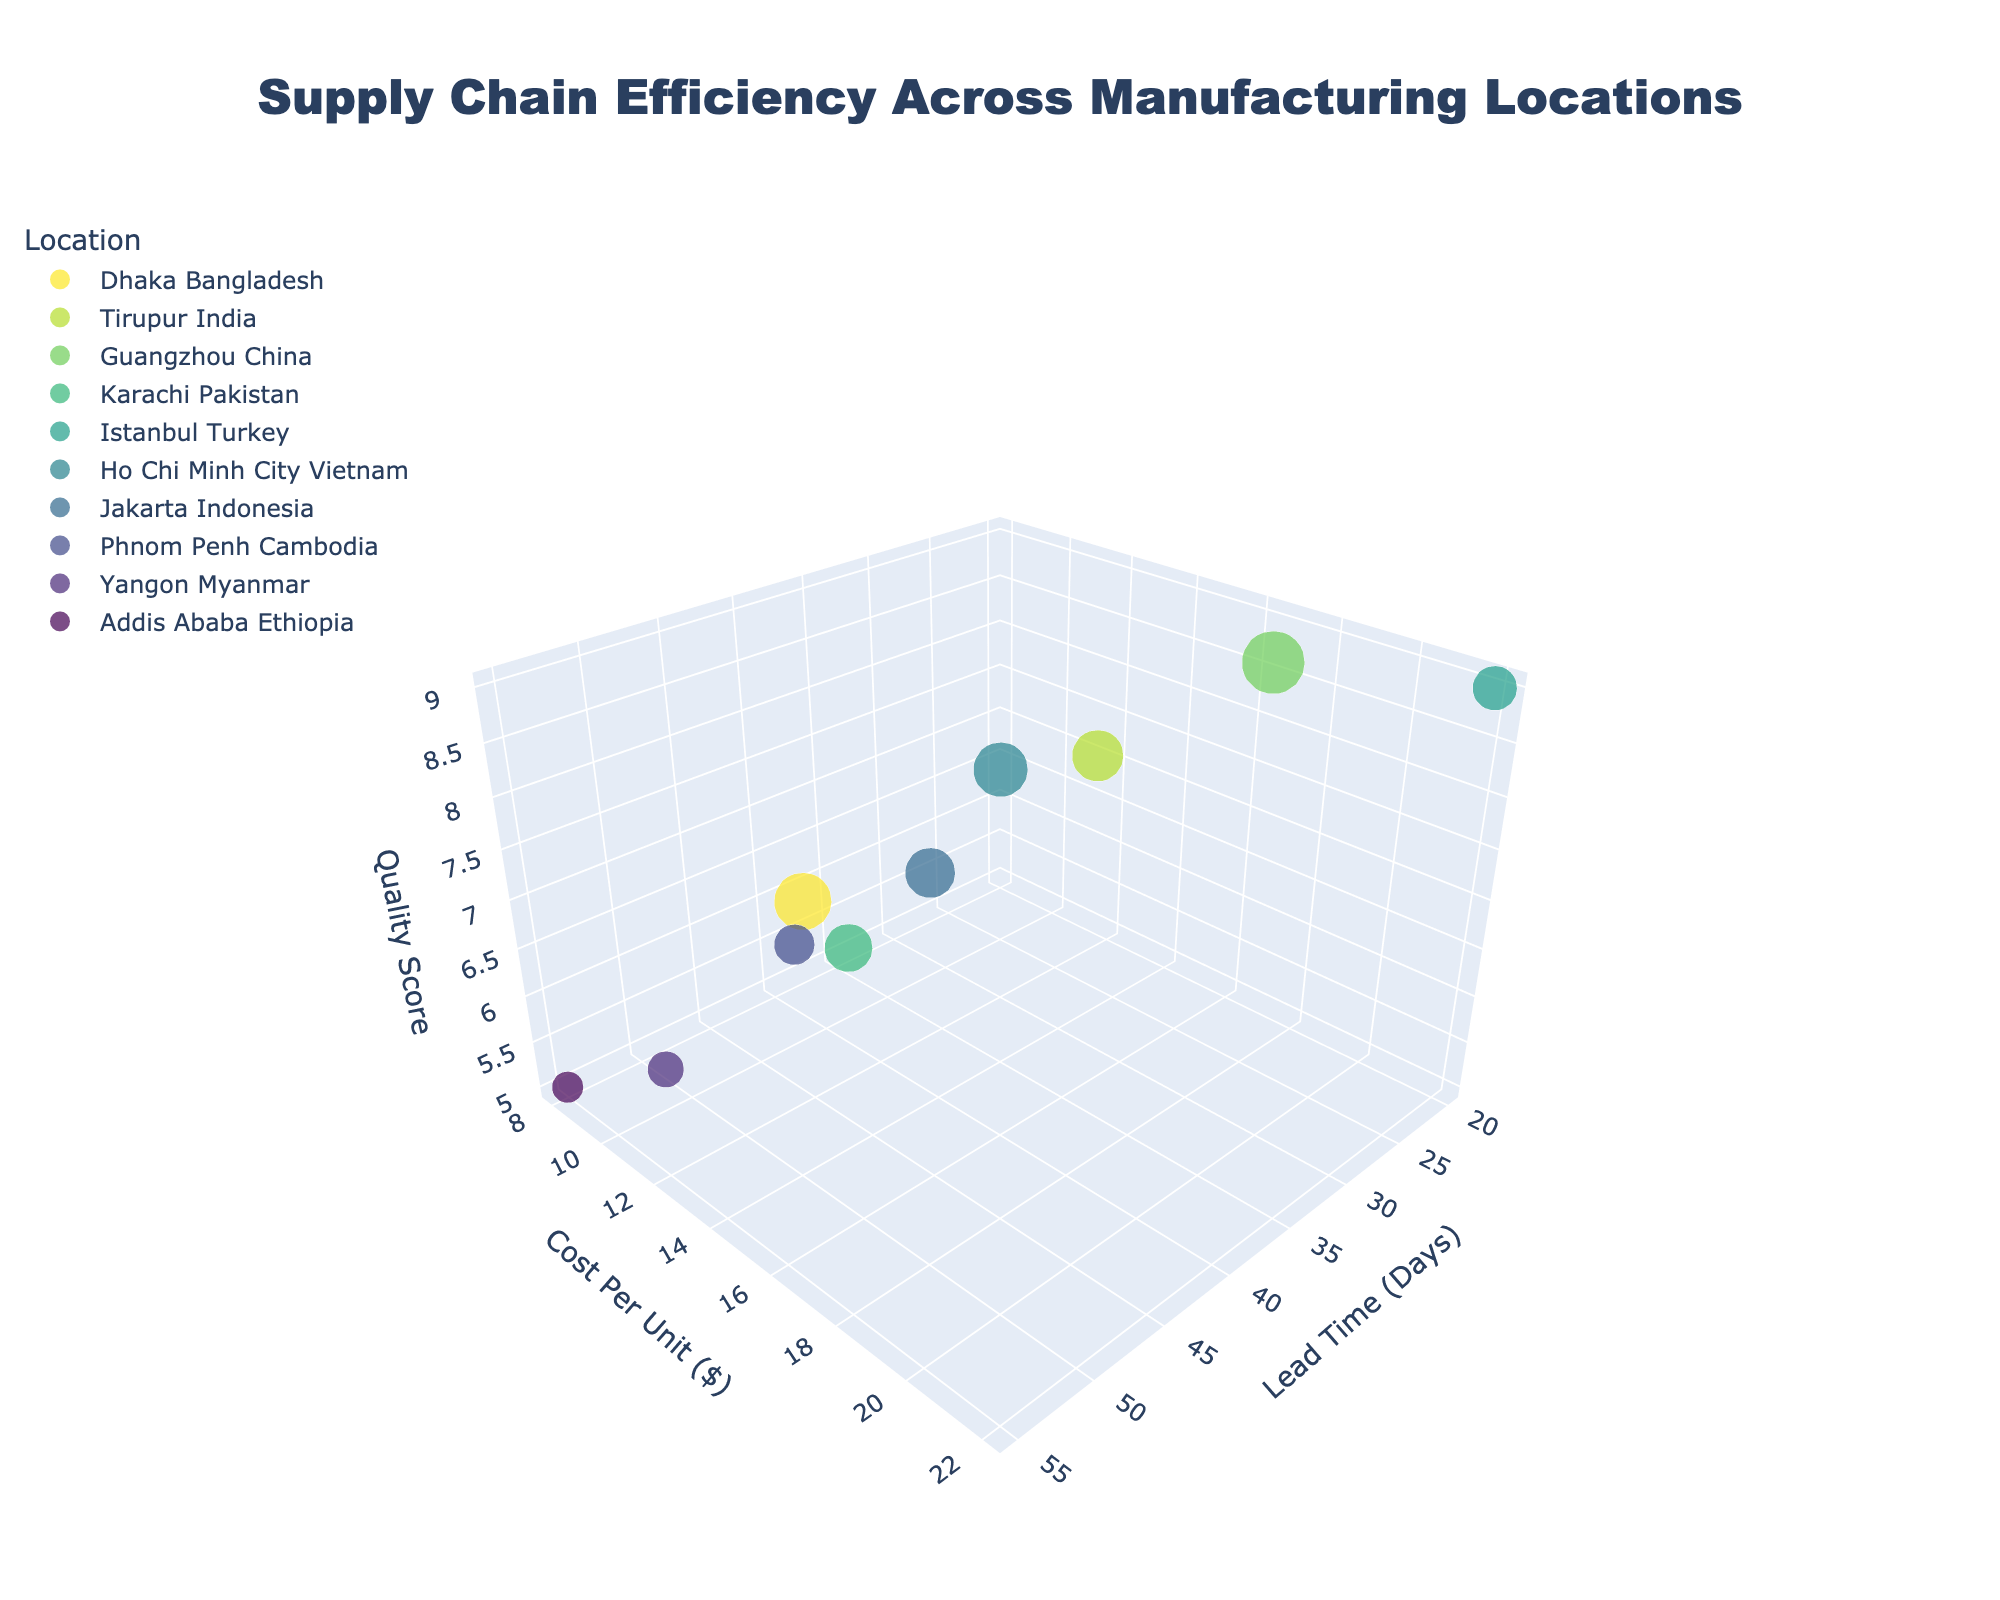How many manufacturing locations are shown in the figure? To find the number of points (each representing a manufacturing location), count the unique locations. From the data provided, there are 10 locations.
Answer: 10 Which location has the highest quality score? Examine the Quality Score axis and identify the point located at the highest value (which is 9 in this case). Two locations have a score of 9: Guangzhou, China, and Istanbul, Turkey.
Answer: Guangzhou, China and Istanbul, Turkey What is the lead time and cost per unit for Ho Chi Minh City, Vietnam? Locate Ho Chi Minh City, Vietnam in the plot, then trace back the values from the Lead Time and Cost Per Unit axes. From the data, the lead time is 35 days and the cost per unit is $14.
Answer: 35 days, $14 Which location has the lowest production volume? Identify the smallest bubble size on the chart. From the data, Addis Ababa, Ethiopia has the smallest production volume of 150,000 units.
Answer: Addis Ababa, Ethiopia Compare the lead time and cost per unit between Guangzhou, China and Tirupur, India. Locate both Guangzhou and Tirupur on the plot, then compare their coordinates on the Lead Time and Cost Per Unit axes. Guangzhou has a lead time of 25 days and cost per unit of $18. Tirupur has a lead time of 30 days and cost per unit of $15.
Answer: Guangzhou: 25 days, $18; Tirupur: 30 days, $15 What is the difference in quality scores between Yangon, Myanmar, and Islamabad, Turkey? Locate both points on the Quality Score axis and calculate the difference. Yangon has a score of 5, and Istanbul has a score of 9. The difference is 9 - 5 = 4.
Answer: 4 Which location has the shortest lead time? Find the point with the smallest x-coordinate on the Lead Time axis. According to the data, Istanbul, Turkey has the shortest lead time of 20 days.
Answer: Istanbul, Turkey What is the average lead time across all locations? Sum all the lead times and divide by the number of locations (10). (45 + 30 + 25 + 40 + 20 + 35 + 38 + 42 + 50 + 55) / 10 = 38 days.
Answer: 38 days Which location offers the most cost-effective production in terms of the lowest cost per unit? Identify the point with the smallest y-coordinate on the Cost Per Unit axis. Addis Ababa, Ethiopia has the lowest cost per unit at $8.
Answer: Addis Ababa, Ethiopia Describe the relationship between lead time and quality score based on the plotted locations. Generally, lower lead times are associated with higher quality scores. Locations like Istanbul and Guangzhou have both low lead times and high quality scores, while locations with higher lead times, like Yangon and Addis Ababa, have lower quality scores.
Answer: Lower lead time typically means higher quality 